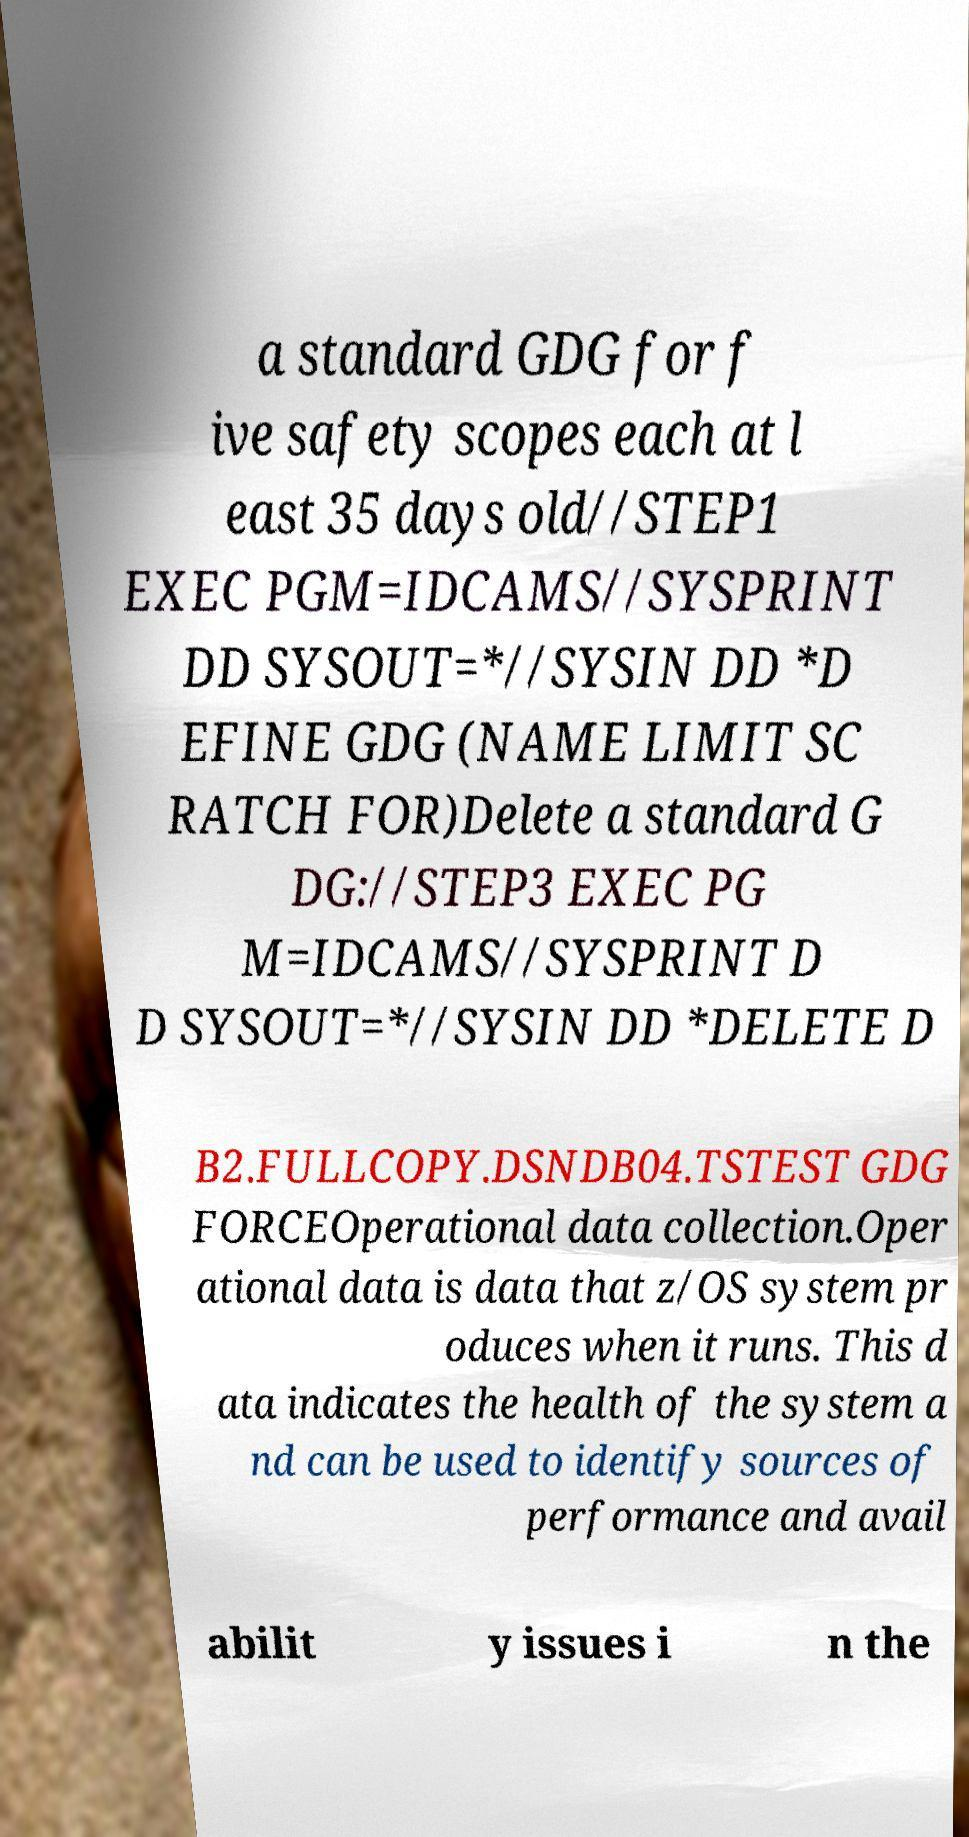Can you accurately transcribe the text from the provided image for me? a standard GDG for f ive safety scopes each at l east 35 days old//STEP1 EXEC PGM=IDCAMS//SYSPRINT DD SYSOUT=*//SYSIN DD *D EFINE GDG (NAME LIMIT SC RATCH FOR)Delete a standard G DG://STEP3 EXEC PG M=IDCAMS//SYSPRINT D D SYSOUT=*//SYSIN DD *DELETE D B2.FULLCOPY.DSNDB04.TSTEST GDG FORCEOperational data collection.Oper ational data is data that z/OS system pr oduces when it runs. This d ata indicates the health of the system a nd can be used to identify sources of performance and avail abilit y issues i n the 